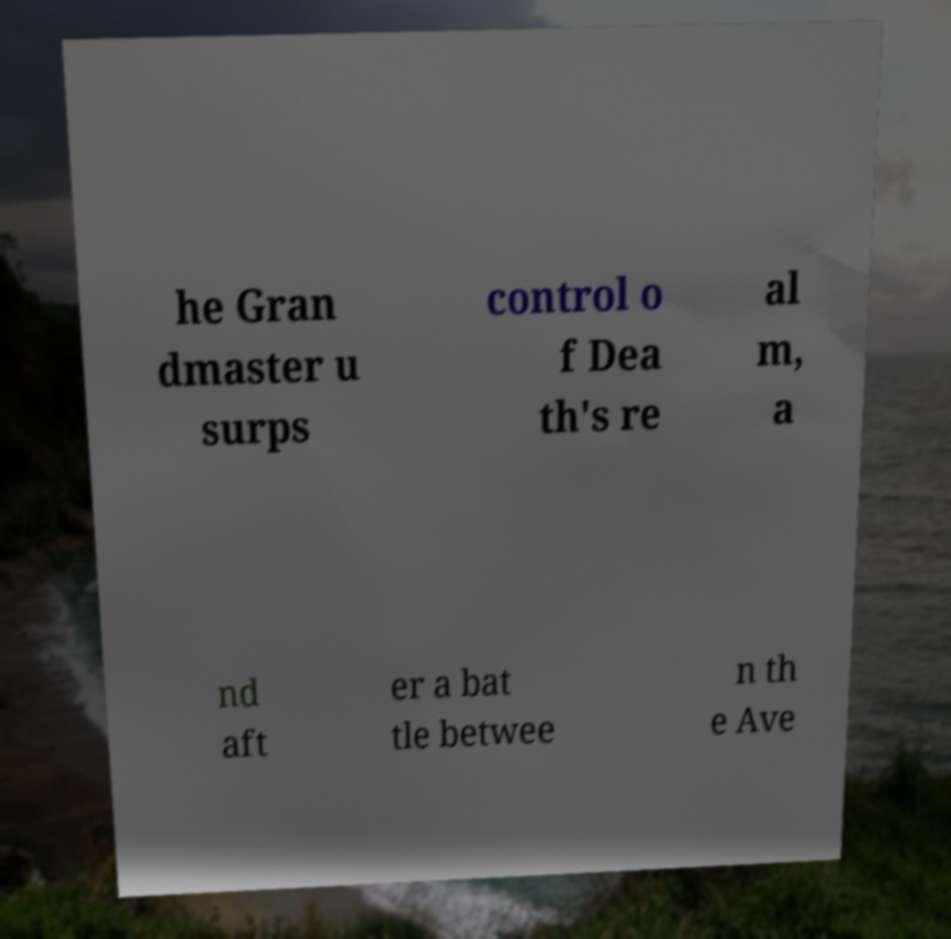Could you extract and type out the text from this image? he Gran dmaster u surps control o f Dea th's re al m, a nd aft er a bat tle betwee n th e Ave 